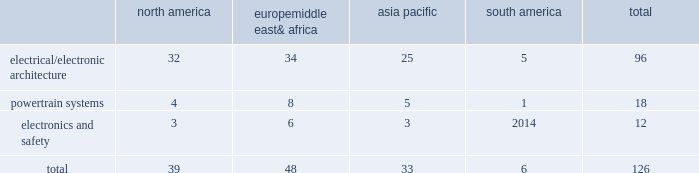Taxing authorities could challenge our historical and future tax positions .
Our future effective tax rates could be affected by changes in the mix of earnings in countries with differing statutory rates and changes in tax laws or their interpretation including changes related to tax holidays or tax incentives .
Our taxes could increase if certain tax holidays or incentives are not renewed upon expiration , or if tax rates or regimes applicable to us in such jurisdictions are otherwise increased .
The amount of tax we pay is subject to our interpretation of applicable tax laws in the jurisdictions in which we file .
We have taken and will continue to take tax positions based on our interpretation of such tax laws .
In particular , we will seek to organize and operate ourselves in such a way that we are and remain tax resident in the united kingdom .
Additionally , in determining the adequacy of our provision for income taxes , we regularly assess the likelihood of adverse outcomes resulting from tax examinations .
While it is often difficult to predict the final outcome or the timing of the resolution of a tax examination , our reserves for uncertain tax benefits reflect the outcome of tax positions that are more likely than not to occur .
While we believe that we have complied with all applicable tax laws , there can be no assurance that a taxing authority will not have a different interpretation of the law and assess us with additional taxes .
Should additional taxes be assessed , this may result in a material adverse effect on our results of operations and financial condition .
Item 1b .
Unresolved staff comments we have no unresolved sec staff comments to report .
Item 2 .
Properties as of december 31 , 2016 , we owned or leased 126 major manufacturing sites and 15 major technical centers .
A manufacturing site may include multiple plants and may be wholly or partially owned or leased .
We also have many smaller manufacturing sites , sales offices , warehouses , engineering centers , joint ventures and other investments strategically located throughout the world .
We have a presence in 46 countries .
The table shows the regional distribution of our major manufacturing sites by the operating segment that uses such facilities : north america europe , middle east & africa asia pacific south america total .
In addition to these manufacturing sites , we had 15 major technical centers : five in north america ; five in europe , middle east and africa ; four in asia pacific ; and one in south america .
Of our 126 major manufacturing sites and 15 major technical centers , which include facilities owned or leased by our consolidated subsidiaries , 75 are primarily owned and 66 are primarily leased .
We frequently review our real estate portfolio and develop footprint strategies to support our customers 2019 global plans , while at the same time supporting our technical needs and controlling operating expenses .
We believe our evolving portfolio will meet current and anticipated future needs .
Item 3 .
Legal proceedings we are from time to time subject to various actions , claims , suits , government investigations , and other proceedings incidental to our business , including those arising out of alleged defects , breach of contracts , competition and antitrust matters , product warranties , intellectual property matters , personal injury claims and employment-related matters .
It is our opinion that the outcome of such matters will not have a material adverse impact on our consolidated financial position , results of operations , or cash flows .
With respect to warranty matters , although we cannot ensure that the future costs of warranty claims by customers will not be material , we believe our established reserves are adequate to cover potential warranty settlements .
However , the final amounts required to resolve these matters could differ materially from our recorded estimates. .
What is the percentage of powertrain systems sites among all sites? 
Rationale: it is the number of sites related to powertrain systems divided by the total sites .
Computations: (18 / 126)
Answer: 0.14286. 